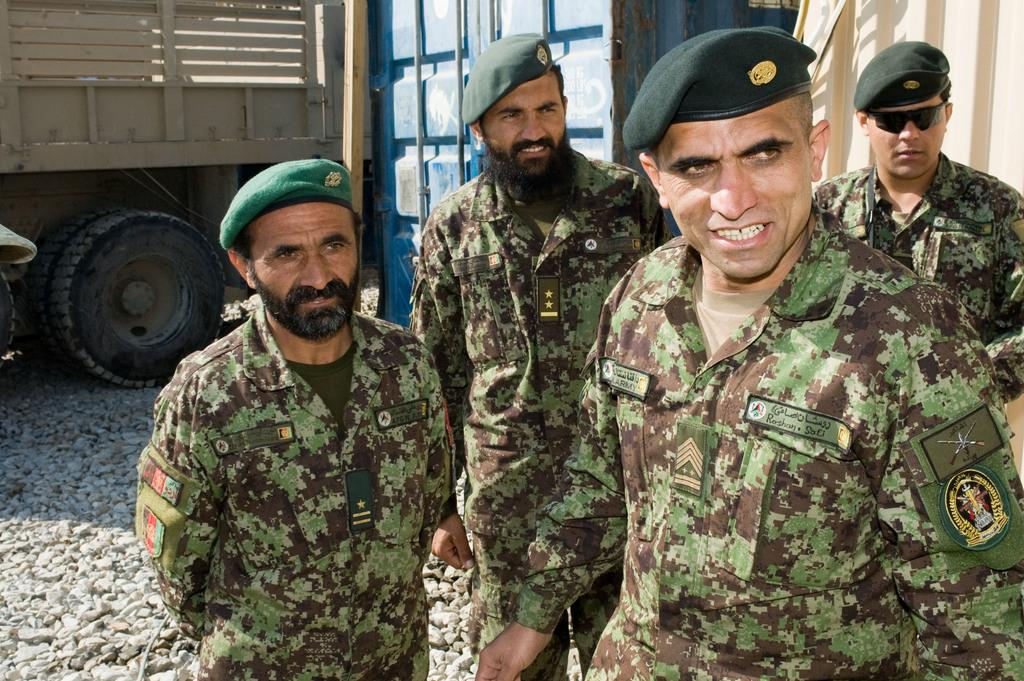What type of people are present in the image? There are soldiers in the image. How are the soldiers dressed? The soldiers are wearing similar dress. What are the soldiers doing in the image? The soldiers are standing. What can be seen in the background of the image? There is a truck and a blue container in the background of the image. What is the color of the truck in the image? The truck is cream-colored. What is the writing speed of the quill used by the soldiers in the image? There is no quill present in the image, and the soldiers are not shown writing. 